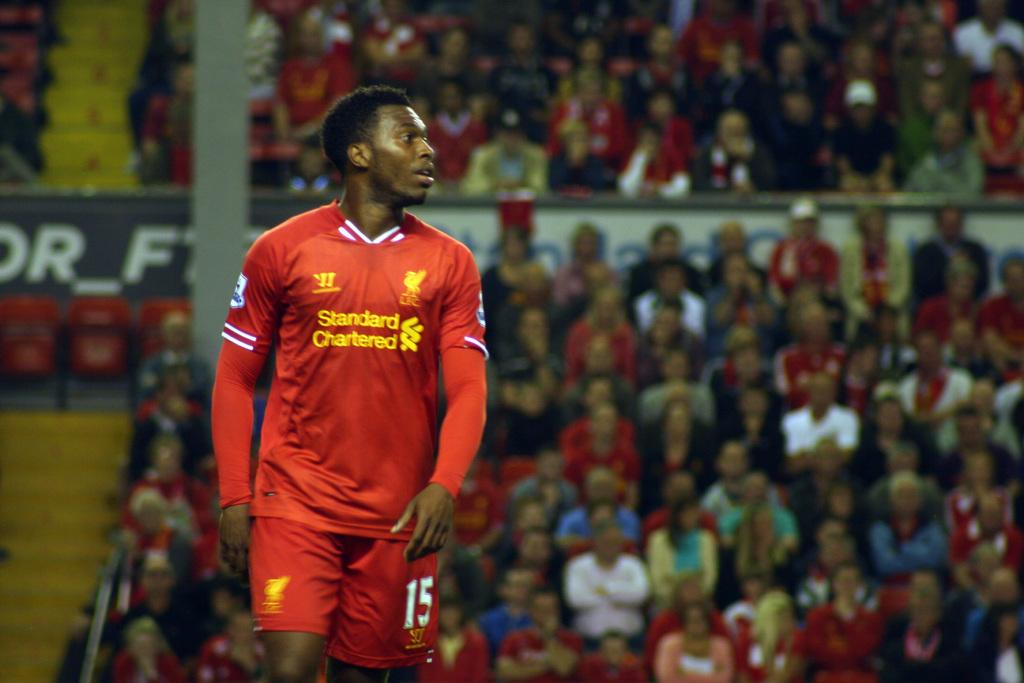<image>
Describe the image concisely. A man is wearing a red jersey that says "Standard Chartered" on the front. 